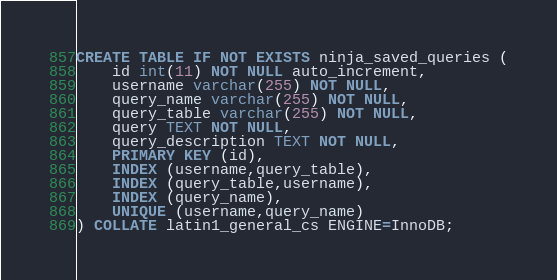Convert code to text. <code><loc_0><loc_0><loc_500><loc_500><_SQL_>CREATE TABLE IF NOT EXISTS ninja_saved_queries (
	id int(11) NOT NULL auto_increment,
	username varchar(255) NOT NULL,
	query_name varchar(255) NOT NULL,
	query_table varchar(255) NOT NULL,
	query TEXT NOT NULL,
	query_description TEXT NOT NULL,
	PRIMARY KEY (id),
	INDEX (username,query_table),
	INDEX (query_table,username),
	INDEX (query_name),
	UNIQUE (username,query_name)
) COLLATE latin1_general_cs ENGINE=InnoDB;</code> 